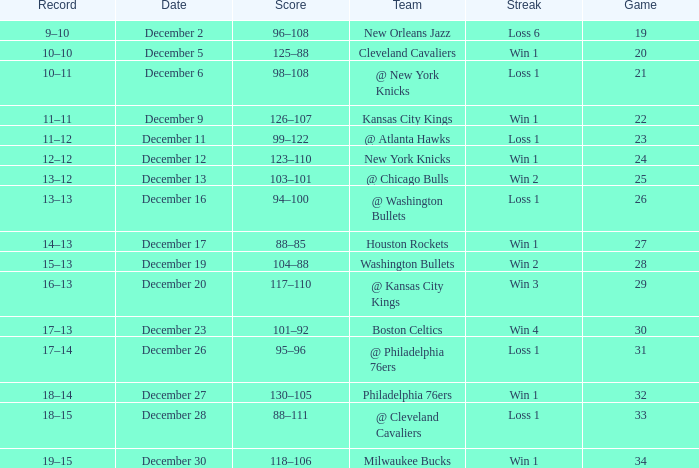What is the Score of the Game with a Record of 13–12? 103–101. 